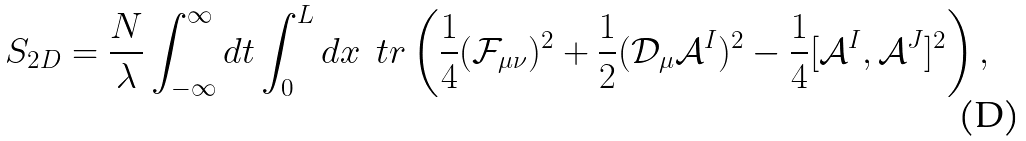Convert formula to latex. <formula><loc_0><loc_0><loc_500><loc_500>S _ { 2 D } = \frac { N } { \lambda } \int ^ { \infty } _ { - \infty } d t \int ^ { L } _ { 0 } d x \, \ t r \left ( \frac { 1 } { 4 } ( \mathcal { F } _ { \mu \nu } ) ^ { 2 } + \frac { 1 } { 2 } ( \mathcal { D } _ { \mu } \mathcal { A } ^ { I } ) ^ { 2 } - \frac { 1 } { 4 } [ \mathcal { A } ^ { I } , \mathcal { A } ^ { J } ] ^ { 2 } \right ) ,</formula> 